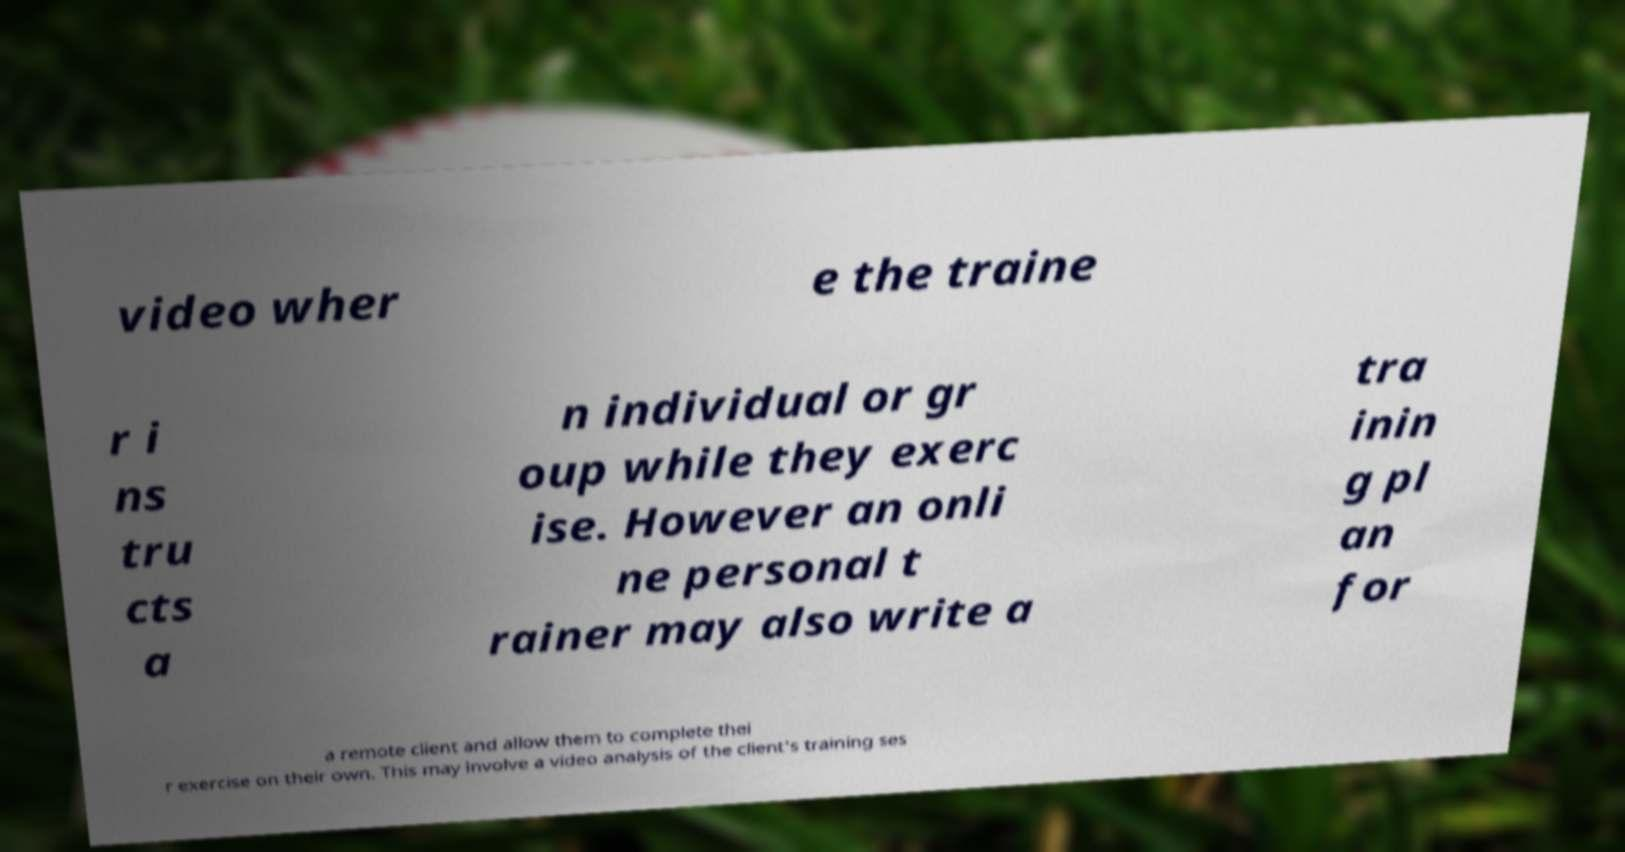Could you extract and type out the text from this image? video wher e the traine r i ns tru cts a n individual or gr oup while they exerc ise. However an onli ne personal t rainer may also write a tra inin g pl an for a remote client and allow them to complete thei r exercise on their own. This may involve a video analysis of the client's training ses 